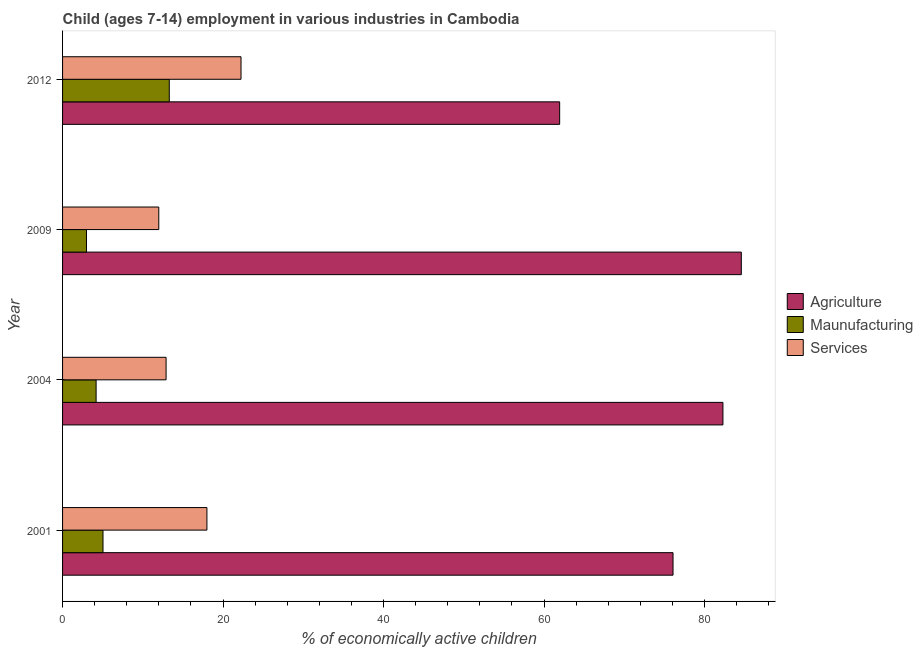Are the number of bars on each tick of the Y-axis equal?
Keep it short and to the point. Yes. What is the label of the 3rd group of bars from the top?
Offer a terse response. 2004. In how many cases, is the number of bars for a given year not equal to the number of legend labels?
Offer a very short reply. 0. What is the percentage of economically active children in manufacturing in 2001?
Offer a very short reply. 5.04. Across all years, what is the maximum percentage of economically active children in manufacturing?
Give a very brief answer. 13.3. Across all years, what is the minimum percentage of economically active children in agriculture?
Your answer should be very brief. 61.95. What is the total percentage of economically active children in manufacturing in the graph?
Your answer should be compact. 25.5. What is the difference between the percentage of economically active children in agriculture in 2001 and that in 2012?
Keep it short and to the point. 14.13. What is the difference between the percentage of economically active children in agriculture in 2001 and the percentage of economically active children in services in 2012?
Your response must be concise. 53.84. What is the average percentage of economically active children in agriculture per year?
Your answer should be compact. 76.23. In the year 2012, what is the difference between the percentage of economically active children in services and percentage of economically active children in manufacturing?
Give a very brief answer. 8.94. What is the ratio of the percentage of economically active children in agriculture in 2001 to that in 2009?
Your answer should be compact. 0.9. Is the percentage of economically active children in agriculture in 2001 less than that in 2012?
Provide a succinct answer. No. Is the difference between the percentage of economically active children in services in 2001 and 2004 greater than the difference between the percentage of economically active children in manufacturing in 2001 and 2004?
Your response must be concise. Yes. What is the difference between the highest and the second highest percentage of economically active children in services?
Provide a short and direct response. 4.25. What is the difference between the highest and the lowest percentage of economically active children in agriculture?
Your answer should be compact. 22.64. Is the sum of the percentage of economically active children in manufacturing in 2004 and 2009 greater than the maximum percentage of economically active children in services across all years?
Offer a very short reply. No. What does the 1st bar from the top in 2001 represents?
Your answer should be very brief. Services. What does the 3rd bar from the bottom in 2012 represents?
Make the answer very short. Services. Is it the case that in every year, the sum of the percentage of economically active children in agriculture and percentage of economically active children in manufacturing is greater than the percentage of economically active children in services?
Your answer should be compact. Yes. How many bars are there?
Ensure brevity in your answer.  12. Are all the bars in the graph horizontal?
Make the answer very short. Yes. How many years are there in the graph?
Your answer should be very brief. 4. What is the difference between two consecutive major ticks on the X-axis?
Provide a short and direct response. 20. Are the values on the major ticks of X-axis written in scientific E-notation?
Your response must be concise. No. Where does the legend appear in the graph?
Ensure brevity in your answer.  Center right. How many legend labels are there?
Offer a terse response. 3. What is the title of the graph?
Provide a succinct answer. Child (ages 7-14) employment in various industries in Cambodia. What is the label or title of the X-axis?
Give a very brief answer. % of economically active children. What is the label or title of the Y-axis?
Provide a succinct answer. Year. What is the % of economically active children in Agriculture in 2001?
Provide a short and direct response. 76.08. What is the % of economically active children of Maunufacturing in 2001?
Your answer should be very brief. 5.04. What is the % of economically active children of Services in 2001?
Ensure brevity in your answer.  17.99. What is the % of economically active children of Agriculture in 2004?
Offer a terse response. 82.3. What is the % of economically active children in Maunufacturing in 2004?
Provide a succinct answer. 4.18. What is the % of economically active children in Agriculture in 2009?
Offer a very short reply. 84.59. What is the % of economically active children in Maunufacturing in 2009?
Keep it short and to the point. 2.98. What is the % of economically active children of Services in 2009?
Your answer should be compact. 11.99. What is the % of economically active children in Agriculture in 2012?
Offer a terse response. 61.95. What is the % of economically active children of Services in 2012?
Offer a terse response. 22.24. Across all years, what is the maximum % of economically active children in Agriculture?
Make the answer very short. 84.59. Across all years, what is the maximum % of economically active children of Maunufacturing?
Offer a terse response. 13.3. Across all years, what is the maximum % of economically active children of Services?
Your answer should be compact. 22.24. Across all years, what is the minimum % of economically active children in Agriculture?
Ensure brevity in your answer.  61.95. Across all years, what is the minimum % of economically active children in Maunufacturing?
Provide a succinct answer. 2.98. Across all years, what is the minimum % of economically active children in Services?
Your response must be concise. 11.99. What is the total % of economically active children of Agriculture in the graph?
Make the answer very short. 304.92. What is the total % of economically active children of Maunufacturing in the graph?
Provide a short and direct response. 25.5. What is the total % of economically active children in Services in the graph?
Provide a succinct answer. 65.12. What is the difference between the % of economically active children in Agriculture in 2001 and that in 2004?
Your answer should be compact. -6.22. What is the difference between the % of economically active children of Maunufacturing in 2001 and that in 2004?
Provide a succinct answer. 0.86. What is the difference between the % of economically active children in Services in 2001 and that in 2004?
Your response must be concise. 5.09. What is the difference between the % of economically active children in Agriculture in 2001 and that in 2009?
Provide a succinct answer. -8.51. What is the difference between the % of economically active children of Maunufacturing in 2001 and that in 2009?
Offer a terse response. 2.06. What is the difference between the % of economically active children in Agriculture in 2001 and that in 2012?
Offer a very short reply. 14.13. What is the difference between the % of economically active children of Maunufacturing in 2001 and that in 2012?
Provide a short and direct response. -8.26. What is the difference between the % of economically active children of Services in 2001 and that in 2012?
Give a very brief answer. -4.25. What is the difference between the % of economically active children in Agriculture in 2004 and that in 2009?
Make the answer very short. -2.29. What is the difference between the % of economically active children in Services in 2004 and that in 2009?
Make the answer very short. 0.91. What is the difference between the % of economically active children of Agriculture in 2004 and that in 2012?
Your response must be concise. 20.35. What is the difference between the % of economically active children in Maunufacturing in 2004 and that in 2012?
Provide a succinct answer. -9.12. What is the difference between the % of economically active children of Services in 2004 and that in 2012?
Your answer should be compact. -9.34. What is the difference between the % of economically active children of Agriculture in 2009 and that in 2012?
Provide a short and direct response. 22.64. What is the difference between the % of economically active children of Maunufacturing in 2009 and that in 2012?
Offer a very short reply. -10.32. What is the difference between the % of economically active children in Services in 2009 and that in 2012?
Provide a short and direct response. -10.25. What is the difference between the % of economically active children of Agriculture in 2001 and the % of economically active children of Maunufacturing in 2004?
Give a very brief answer. 71.9. What is the difference between the % of economically active children of Agriculture in 2001 and the % of economically active children of Services in 2004?
Your response must be concise. 63.18. What is the difference between the % of economically active children of Maunufacturing in 2001 and the % of economically active children of Services in 2004?
Your response must be concise. -7.86. What is the difference between the % of economically active children of Agriculture in 2001 and the % of economically active children of Maunufacturing in 2009?
Provide a short and direct response. 73.1. What is the difference between the % of economically active children of Agriculture in 2001 and the % of economically active children of Services in 2009?
Give a very brief answer. 64.09. What is the difference between the % of economically active children of Maunufacturing in 2001 and the % of economically active children of Services in 2009?
Provide a short and direct response. -6.95. What is the difference between the % of economically active children of Agriculture in 2001 and the % of economically active children of Maunufacturing in 2012?
Give a very brief answer. 62.78. What is the difference between the % of economically active children in Agriculture in 2001 and the % of economically active children in Services in 2012?
Keep it short and to the point. 53.84. What is the difference between the % of economically active children in Maunufacturing in 2001 and the % of economically active children in Services in 2012?
Your answer should be very brief. -17.2. What is the difference between the % of economically active children of Agriculture in 2004 and the % of economically active children of Maunufacturing in 2009?
Provide a succinct answer. 79.32. What is the difference between the % of economically active children of Agriculture in 2004 and the % of economically active children of Services in 2009?
Make the answer very short. 70.31. What is the difference between the % of economically active children in Maunufacturing in 2004 and the % of economically active children in Services in 2009?
Your response must be concise. -7.81. What is the difference between the % of economically active children of Agriculture in 2004 and the % of economically active children of Services in 2012?
Offer a terse response. 60.06. What is the difference between the % of economically active children in Maunufacturing in 2004 and the % of economically active children in Services in 2012?
Keep it short and to the point. -18.06. What is the difference between the % of economically active children of Agriculture in 2009 and the % of economically active children of Maunufacturing in 2012?
Your answer should be very brief. 71.29. What is the difference between the % of economically active children of Agriculture in 2009 and the % of economically active children of Services in 2012?
Offer a very short reply. 62.35. What is the difference between the % of economically active children in Maunufacturing in 2009 and the % of economically active children in Services in 2012?
Your answer should be very brief. -19.26. What is the average % of economically active children of Agriculture per year?
Ensure brevity in your answer.  76.23. What is the average % of economically active children of Maunufacturing per year?
Ensure brevity in your answer.  6.38. What is the average % of economically active children of Services per year?
Make the answer very short. 16.28. In the year 2001, what is the difference between the % of economically active children in Agriculture and % of economically active children in Maunufacturing?
Your answer should be compact. 71.04. In the year 2001, what is the difference between the % of economically active children in Agriculture and % of economically active children in Services?
Provide a short and direct response. 58.09. In the year 2001, what is the difference between the % of economically active children in Maunufacturing and % of economically active children in Services?
Offer a terse response. -12.95. In the year 2004, what is the difference between the % of economically active children of Agriculture and % of economically active children of Maunufacturing?
Your answer should be compact. 78.12. In the year 2004, what is the difference between the % of economically active children of Agriculture and % of economically active children of Services?
Give a very brief answer. 69.4. In the year 2004, what is the difference between the % of economically active children of Maunufacturing and % of economically active children of Services?
Provide a short and direct response. -8.72. In the year 2009, what is the difference between the % of economically active children of Agriculture and % of economically active children of Maunufacturing?
Ensure brevity in your answer.  81.61. In the year 2009, what is the difference between the % of economically active children in Agriculture and % of economically active children in Services?
Offer a terse response. 72.6. In the year 2009, what is the difference between the % of economically active children of Maunufacturing and % of economically active children of Services?
Keep it short and to the point. -9.01. In the year 2012, what is the difference between the % of economically active children of Agriculture and % of economically active children of Maunufacturing?
Offer a very short reply. 48.65. In the year 2012, what is the difference between the % of economically active children in Agriculture and % of economically active children in Services?
Provide a succinct answer. 39.71. In the year 2012, what is the difference between the % of economically active children of Maunufacturing and % of economically active children of Services?
Your answer should be very brief. -8.94. What is the ratio of the % of economically active children of Agriculture in 2001 to that in 2004?
Keep it short and to the point. 0.92. What is the ratio of the % of economically active children of Maunufacturing in 2001 to that in 2004?
Your answer should be very brief. 1.21. What is the ratio of the % of economically active children in Services in 2001 to that in 2004?
Provide a succinct answer. 1.39. What is the ratio of the % of economically active children in Agriculture in 2001 to that in 2009?
Give a very brief answer. 0.9. What is the ratio of the % of economically active children of Maunufacturing in 2001 to that in 2009?
Ensure brevity in your answer.  1.69. What is the ratio of the % of economically active children of Services in 2001 to that in 2009?
Offer a terse response. 1.5. What is the ratio of the % of economically active children of Agriculture in 2001 to that in 2012?
Provide a short and direct response. 1.23. What is the ratio of the % of economically active children in Maunufacturing in 2001 to that in 2012?
Offer a very short reply. 0.38. What is the ratio of the % of economically active children of Services in 2001 to that in 2012?
Ensure brevity in your answer.  0.81. What is the ratio of the % of economically active children of Agriculture in 2004 to that in 2009?
Give a very brief answer. 0.97. What is the ratio of the % of economically active children of Maunufacturing in 2004 to that in 2009?
Your response must be concise. 1.4. What is the ratio of the % of economically active children of Services in 2004 to that in 2009?
Offer a terse response. 1.08. What is the ratio of the % of economically active children of Agriculture in 2004 to that in 2012?
Provide a succinct answer. 1.33. What is the ratio of the % of economically active children of Maunufacturing in 2004 to that in 2012?
Your answer should be very brief. 0.31. What is the ratio of the % of economically active children in Services in 2004 to that in 2012?
Offer a very short reply. 0.58. What is the ratio of the % of economically active children of Agriculture in 2009 to that in 2012?
Keep it short and to the point. 1.37. What is the ratio of the % of economically active children in Maunufacturing in 2009 to that in 2012?
Give a very brief answer. 0.22. What is the ratio of the % of economically active children in Services in 2009 to that in 2012?
Your response must be concise. 0.54. What is the difference between the highest and the second highest % of economically active children in Agriculture?
Offer a terse response. 2.29. What is the difference between the highest and the second highest % of economically active children in Maunufacturing?
Your answer should be compact. 8.26. What is the difference between the highest and the second highest % of economically active children of Services?
Your answer should be compact. 4.25. What is the difference between the highest and the lowest % of economically active children of Agriculture?
Your response must be concise. 22.64. What is the difference between the highest and the lowest % of economically active children of Maunufacturing?
Keep it short and to the point. 10.32. What is the difference between the highest and the lowest % of economically active children of Services?
Ensure brevity in your answer.  10.25. 